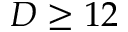<formula> <loc_0><loc_0><loc_500><loc_500>D \geq 1 2</formula> 